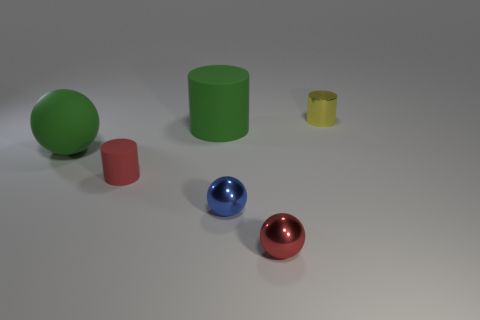What is the blue sphere made of?
Your response must be concise. Metal. What is the color of the object that is behind the red ball and in front of the small red matte cylinder?
Make the answer very short. Blue. What number of small cylinders are on the left side of the tiny object that is behind the big green sphere?
Your answer should be very brief. 1. Are there any other red things that have the same shape as the red matte object?
Your response must be concise. No. There is a small shiny object that is on the right side of the small red metal sphere; is its shape the same as the big green rubber thing to the right of the large green sphere?
Your answer should be very brief. Yes. What number of things are either gray metal blocks or big green cylinders?
Your response must be concise. 1. What size is the red thing that is the same shape as the small blue thing?
Ensure brevity in your answer.  Small. Are there more red shiny spheres that are on the right side of the red sphere than yellow metal cylinders?
Make the answer very short. No. Is the green sphere made of the same material as the large green cylinder?
Ensure brevity in your answer.  Yes. How many objects are either tiny objects to the left of the big cylinder or small shiny things on the right side of the blue metallic ball?
Give a very brief answer. 3. 